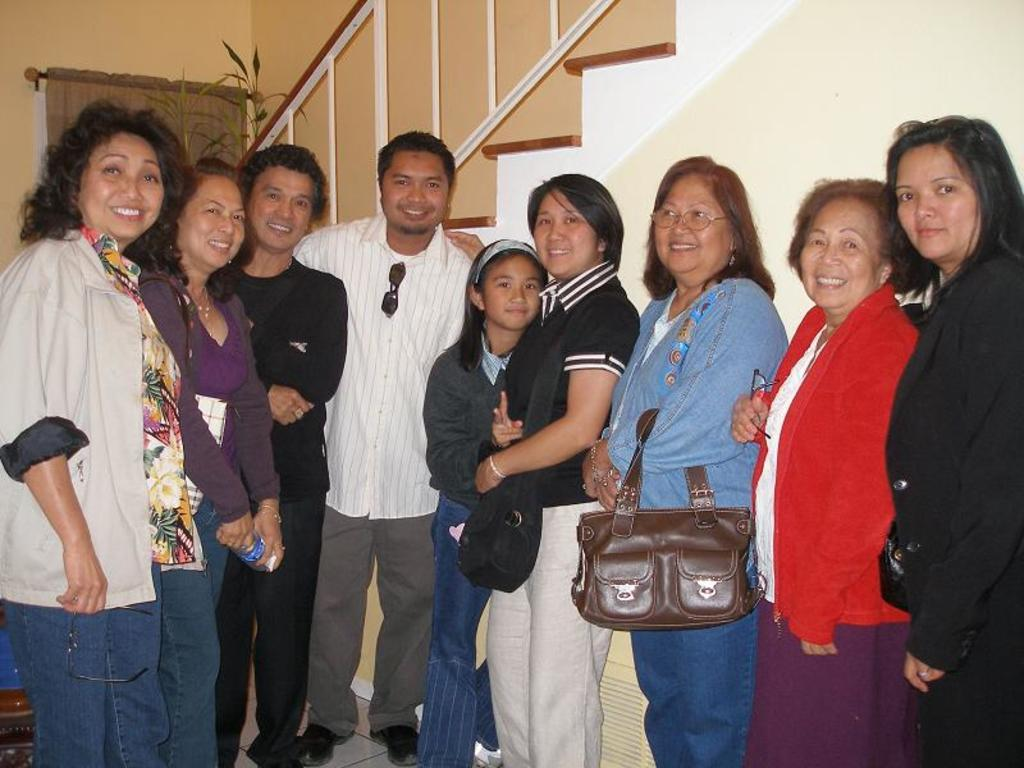What are the people in the image standing on? There is a group of people standing on a path in the image. What architectural feature can be seen in the image? There is a staircase in the image. What can be seen in the background of the image? There is a curtain and plants in the background of the image. What type of organization is depicted in the image? There is no organization depicted in the image; it features a group of people standing on a path, a staircase, and a background with a curtain and plants. Can you see any cobwebs in the image? There are no cobwebs present in the image. 